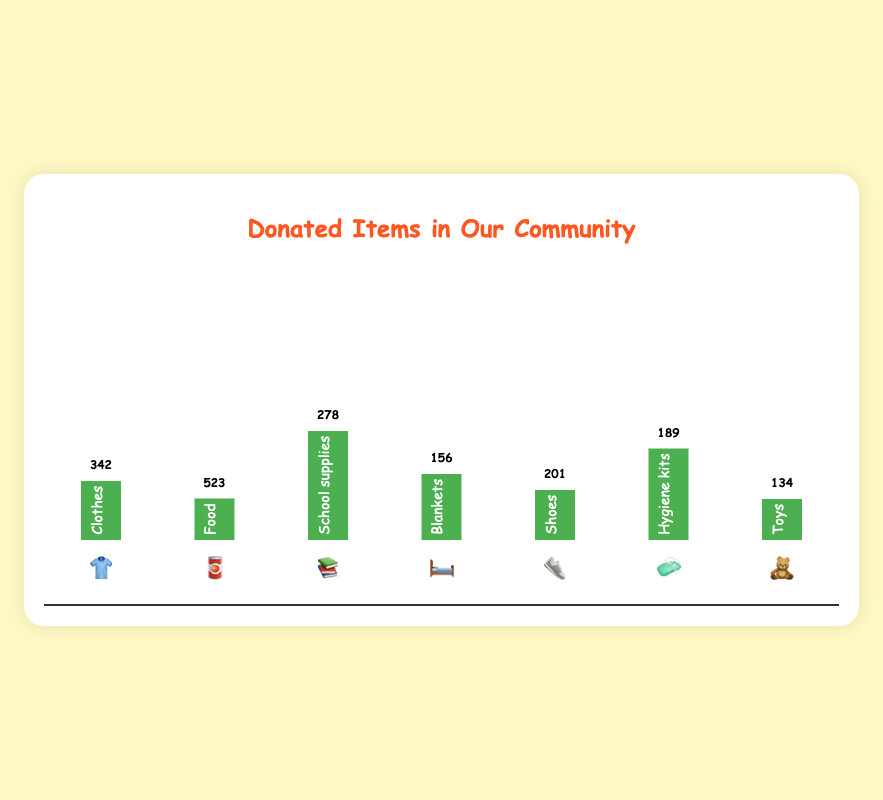Which item has the highest amount of donations? First, identify the item with the tallest bar in the chart. The tallest bar corresponds to 'Food 🥫', with the highest donation amount.
Answer: Food 🥫 Which item has the lowest amount of donations? Look for the shortest bar in the chart. The shortest bar corresponds to 'Toys 🧸', which has the lowest donation amount.
Answer: Toys 🧸 How many more 'Food' 🥫 donations were there than 'Toys' 🧸? Subtract the number of 'Toys' 🧸 donations (134) from the number of 'Food' 🥫 donations (523). 523 - 134 = 389.
Answer: 389 What is the difference in donations between 'Clothes' 👕 and 'Shoes' 👟? Subtract the number of 'Shoes' 👟 donations (201) from the number of 'Clothes' 👕 donations (342). 342 - 201 = 141.
Answer: 141 What is the combined total of donations for 'School supplies' 📚 and 'Blankets' 🛏️? Add the number of 'School supplies' 📚 donations (278) to the number of 'Blankets' 🛏️ donations (156). 278 + 156 = 434.
Answer: 434 Are there more 'Hygiene kits' 🧼 or 'Shoes' 👟 donations? Compare the number of 'Hygiene kits' 🧼 donations (189) with the number of 'Shoes' 👟 donations (201). 201 > 189, so there are more 'Shoes' 👟 donations.
Answer: Shoes 👟 What is the average amount of the donations for all items? Add up all the donation amounts and divide by the number of items. (342 + 523 + 278 + 156 + 201 + 189 + 134) / 7 = 260.43.
Answer: 260.43 By how much do 'Blankets' 🛏️ donations fall short compared to the average amount? First, find the average amount of donations (260.43). Then subtract the number of 'Blankets' 🛏️ donations (156) from this average. 260.43 - 156 = 104.43.
Answer: 104.43 Which items have more than 300 donations? Identify the items with their donation amounts greater than 300. 'Clothes' 👕 (342) and 'Food' 🥫 (523) both have more than 300 donations.
Answer: Clothes 👕 and Food 🥫 